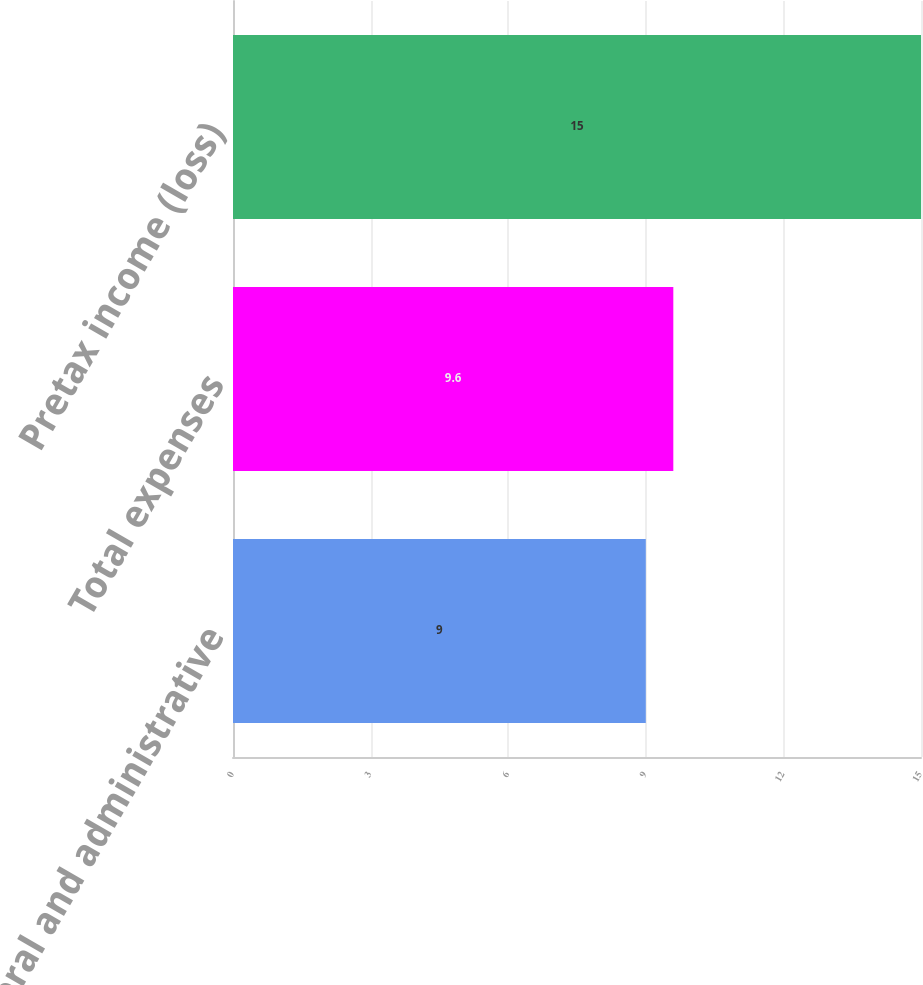Convert chart. <chart><loc_0><loc_0><loc_500><loc_500><bar_chart><fcel>General and administrative<fcel>Total expenses<fcel>Pretax income (loss)<nl><fcel>9<fcel>9.6<fcel>15<nl></chart> 